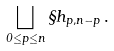<formula> <loc_0><loc_0><loc_500><loc_500>\bigsqcup _ { 0 \leq p \leq n } \S h _ { p , n - p } \, .</formula> 